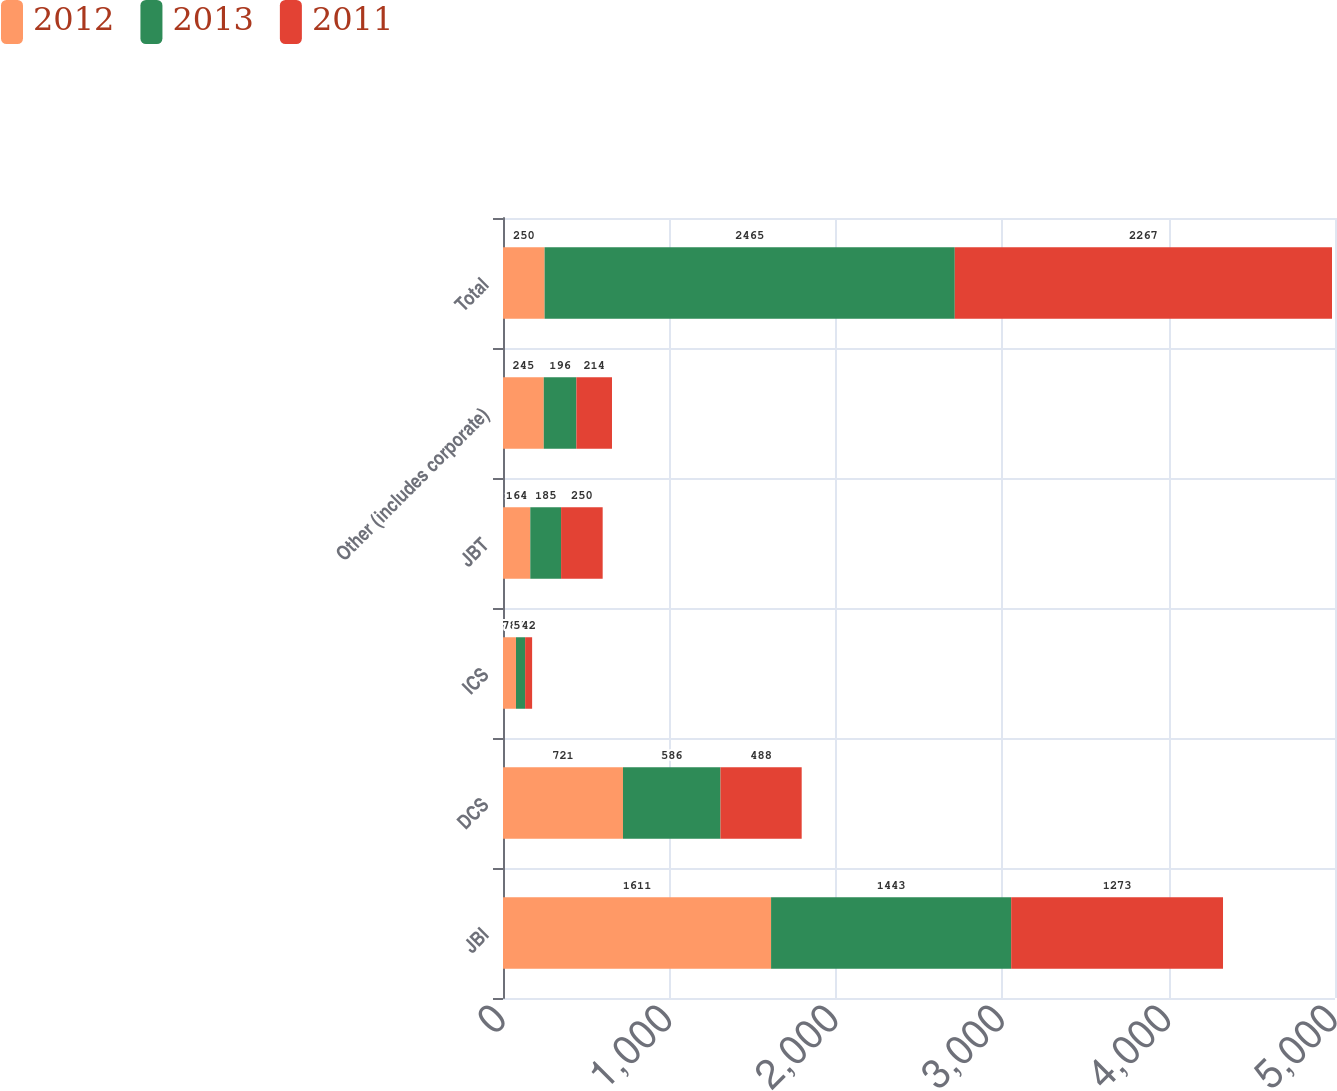<chart> <loc_0><loc_0><loc_500><loc_500><stacked_bar_chart><ecel><fcel>JBI<fcel>DCS<fcel>ICS<fcel>JBT<fcel>Other (includes corporate)<fcel>Total<nl><fcel>2012<fcel>1611<fcel>721<fcel>78<fcel>164<fcel>245<fcel>250<nl><fcel>2013<fcel>1443<fcel>586<fcel>55<fcel>185<fcel>196<fcel>2465<nl><fcel>2011<fcel>1273<fcel>488<fcel>42<fcel>250<fcel>214<fcel>2267<nl></chart> 